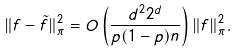Convert formula to latex. <formula><loc_0><loc_0><loc_500><loc_500>\| f - \tilde { f } \| _ { \pi } ^ { 2 } = O \left ( \frac { d ^ { 2 } 2 ^ { d } } { p ( 1 - p ) n } \right ) \| f \| _ { \pi } ^ { 2 } .</formula> 